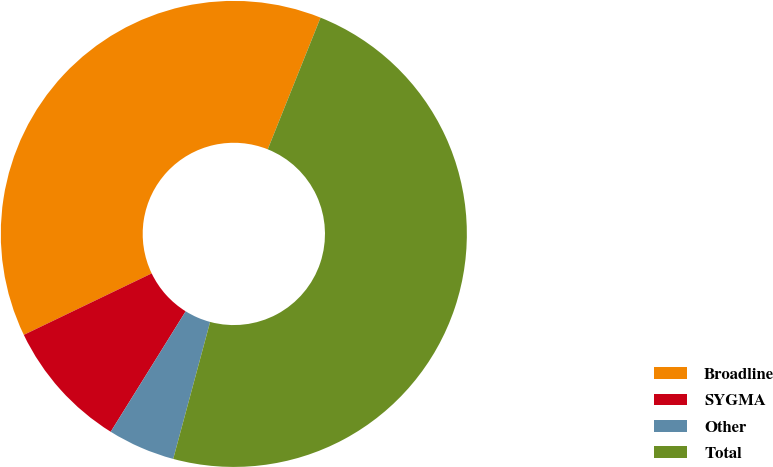<chart> <loc_0><loc_0><loc_500><loc_500><pie_chart><fcel>Broadline<fcel>SYGMA<fcel>Other<fcel>Total<nl><fcel>38.2%<fcel>9.01%<fcel>4.67%<fcel>48.12%<nl></chart> 